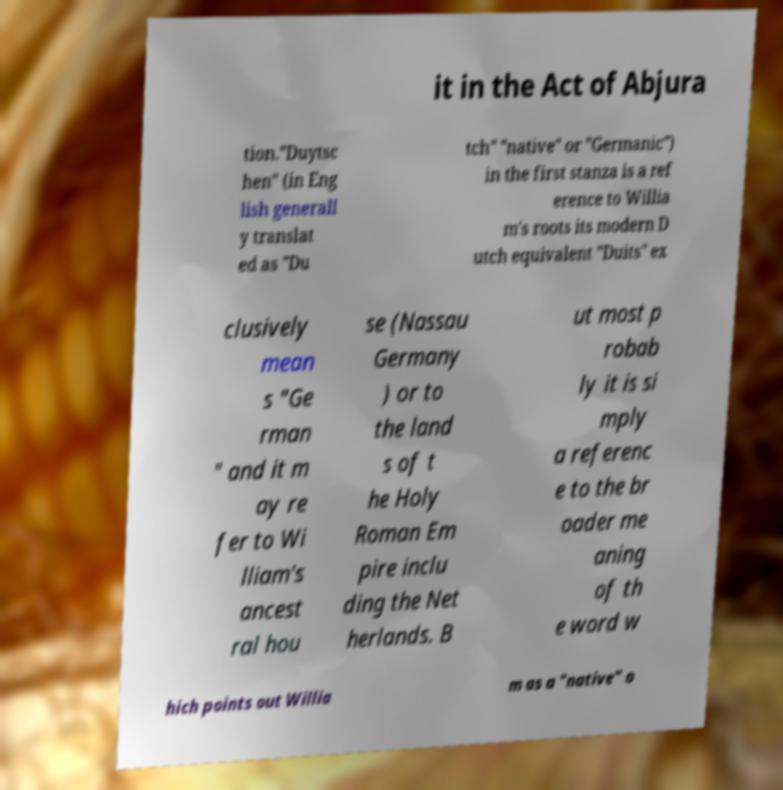I need the written content from this picture converted into text. Can you do that? it in the Act of Abjura tion."Duytsc hen" (in Eng lish generall y translat ed as "Du tch" "native" or "Germanic") in the first stanza is a ref erence to Willia m's roots its modern D utch equivalent "Duits" ex clusively mean s "Ge rman " and it m ay re fer to Wi lliam's ancest ral hou se (Nassau Germany ) or to the land s of t he Holy Roman Em pire inclu ding the Net herlands. B ut most p robab ly it is si mply a referenc e to the br oader me aning of th e word w hich points out Willia m as a "native" o 